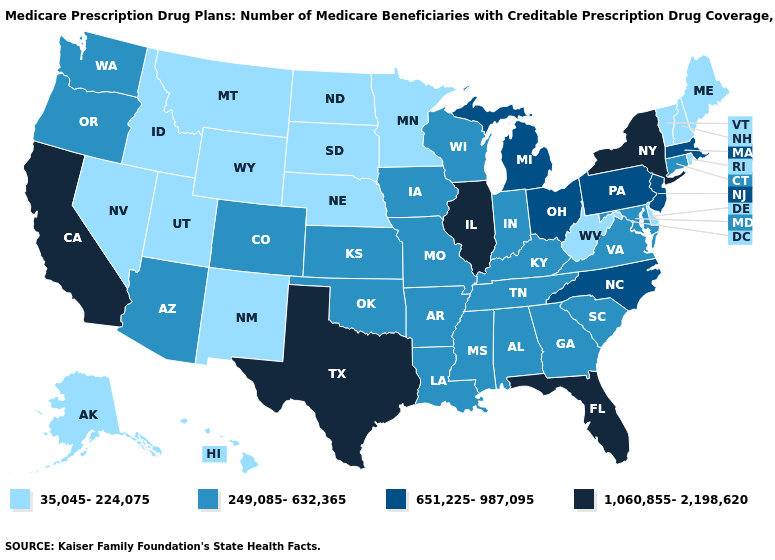Which states hav the highest value in the Northeast?
Be succinct. New York. What is the value of Massachusetts?
Concise answer only. 651,225-987,095. What is the value of New York?
Give a very brief answer. 1,060,855-2,198,620. What is the value of South Carolina?
Be succinct. 249,085-632,365. What is the value of Alabama?
Keep it brief. 249,085-632,365. What is the value of Louisiana?
Be succinct. 249,085-632,365. What is the highest value in the USA?
Give a very brief answer. 1,060,855-2,198,620. Which states have the lowest value in the USA?
Short answer required. Alaska, Delaware, Hawaii, Idaho, Maine, Minnesota, Montana, Nebraska, Nevada, New Hampshire, New Mexico, North Dakota, Rhode Island, South Dakota, Utah, Vermont, West Virginia, Wyoming. Does Massachusetts have the lowest value in the Northeast?
Quick response, please. No. What is the value of Kansas?
Give a very brief answer. 249,085-632,365. Does the first symbol in the legend represent the smallest category?
Write a very short answer. Yes. Does the first symbol in the legend represent the smallest category?
Quick response, please. Yes. Does Maine have the lowest value in the Northeast?
Concise answer only. Yes. What is the value of Massachusetts?
Be succinct. 651,225-987,095. Name the states that have a value in the range 651,225-987,095?
Answer briefly. Massachusetts, Michigan, New Jersey, North Carolina, Ohio, Pennsylvania. 